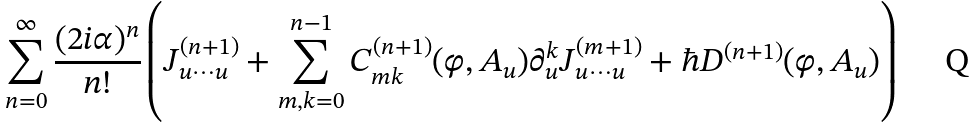Convert formula to latex. <formula><loc_0><loc_0><loc_500><loc_500>\sum _ { n = 0 } ^ { \infty } \frac { ( 2 i \alpha ) ^ { n } } { n ! } \left ( J ^ { ( n + 1 ) } _ { u \cdots u } + \sum _ { m , k = 0 } ^ { n - 1 } C _ { m k } ^ { ( n + 1 ) } ( \varphi , A _ { u } ) \partial _ { u } ^ { k } J ^ { ( m + 1 ) } _ { u \cdots u } + \hbar { D } ^ { ( n + 1 ) } ( \varphi , A _ { u } ) \right )</formula> 